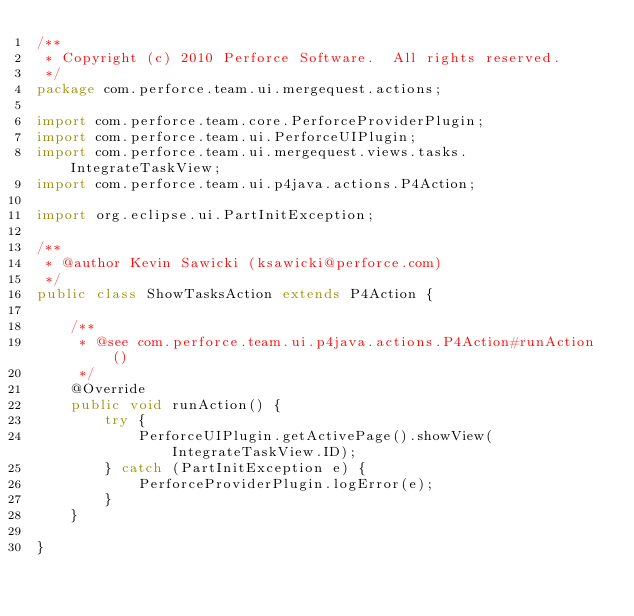Convert code to text. <code><loc_0><loc_0><loc_500><loc_500><_Java_>/**
 * Copyright (c) 2010 Perforce Software.  All rights reserved.
 */
package com.perforce.team.ui.mergequest.actions;

import com.perforce.team.core.PerforceProviderPlugin;
import com.perforce.team.ui.PerforceUIPlugin;
import com.perforce.team.ui.mergequest.views.tasks.IntegrateTaskView;
import com.perforce.team.ui.p4java.actions.P4Action;

import org.eclipse.ui.PartInitException;

/**
 * @author Kevin Sawicki (ksawicki@perforce.com)
 */
public class ShowTasksAction extends P4Action {

    /**
     * @see com.perforce.team.ui.p4java.actions.P4Action#runAction()
     */
    @Override
    public void runAction() {
        try {
            PerforceUIPlugin.getActivePage().showView(IntegrateTaskView.ID);
        } catch (PartInitException e) {
            PerforceProviderPlugin.logError(e);
        }
    }

}
</code> 